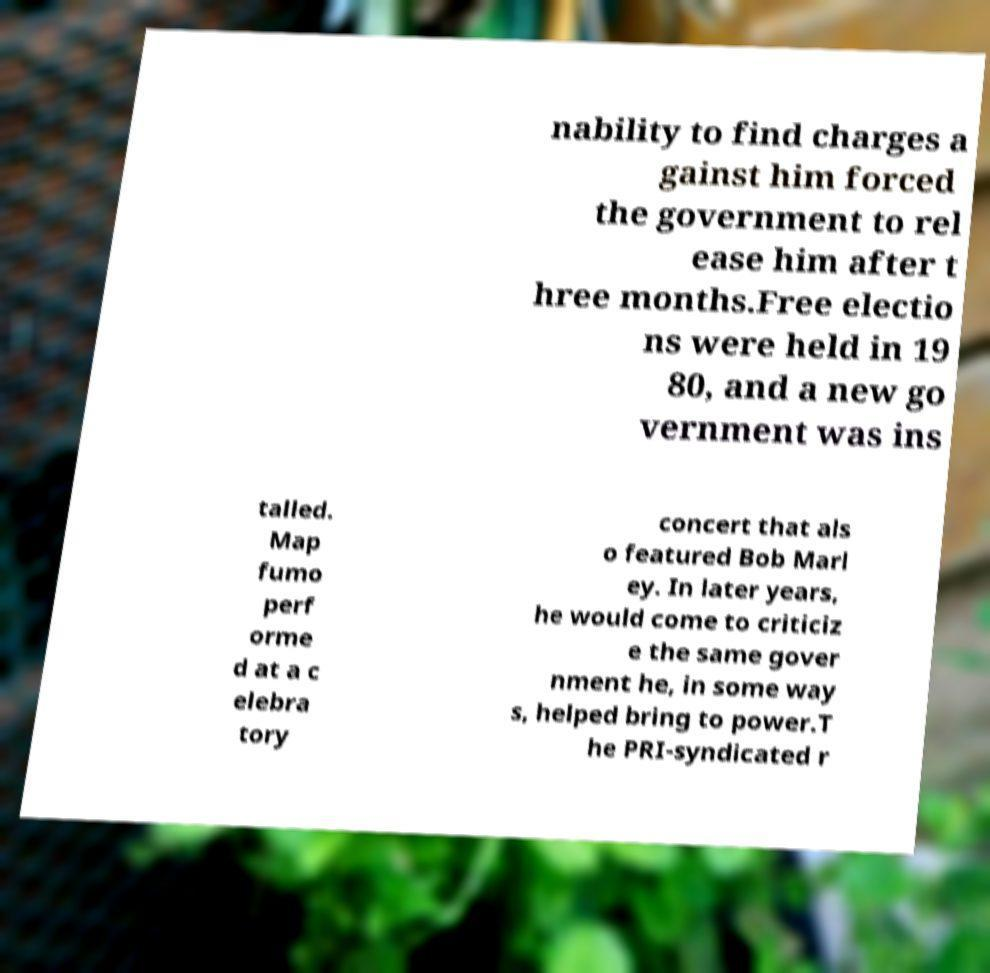I need the written content from this picture converted into text. Can you do that? nability to find charges a gainst him forced the government to rel ease him after t hree months.Free electio ns were held in 19 80, and a new go vernment was ins talled. Map fumo perf orme d at a c elebra tory concert that als o featured Bob Marl ey. In later years, he would come to criticiz e the same gover nment he, in some way s, helped bring to power.T he PRI-syndicated r 